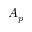<formula> <loc_0><loc_0><loc_500><loc_500>A _ { p }</formula> 